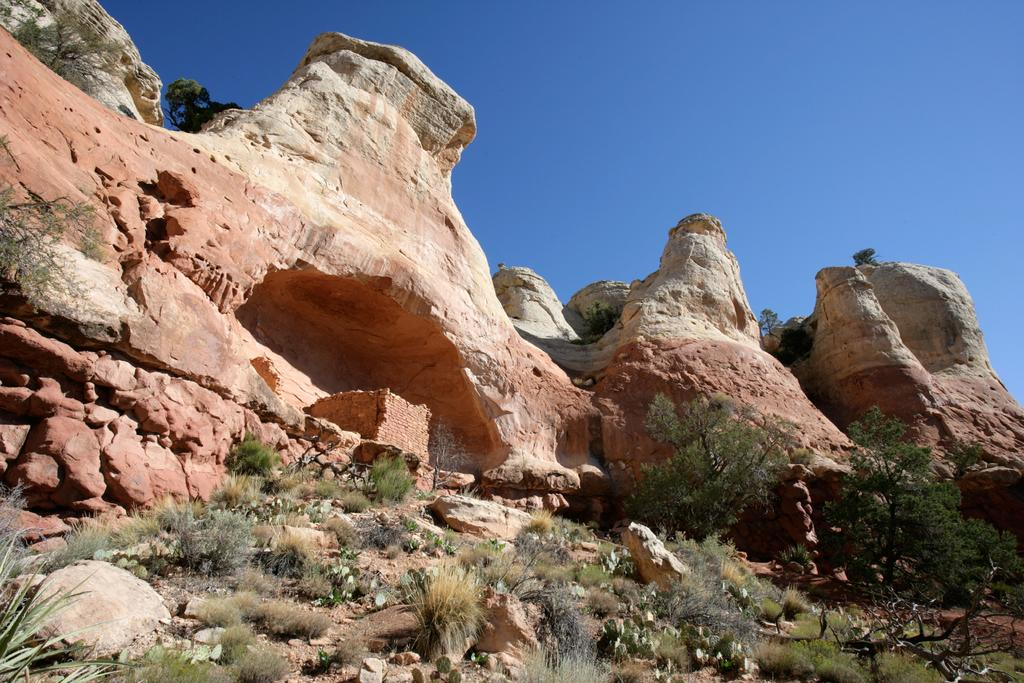What type of landscape is depicted in the image? The image features hills. What type of vegetation can be seen in the image? There is grass and trees in the image. What color is the sky in the image? The sky is blue in the image. How many hands are visible in the image? There are no hands visible in the image; it features a landscape with hills, grass, trees, and a blue sky. 